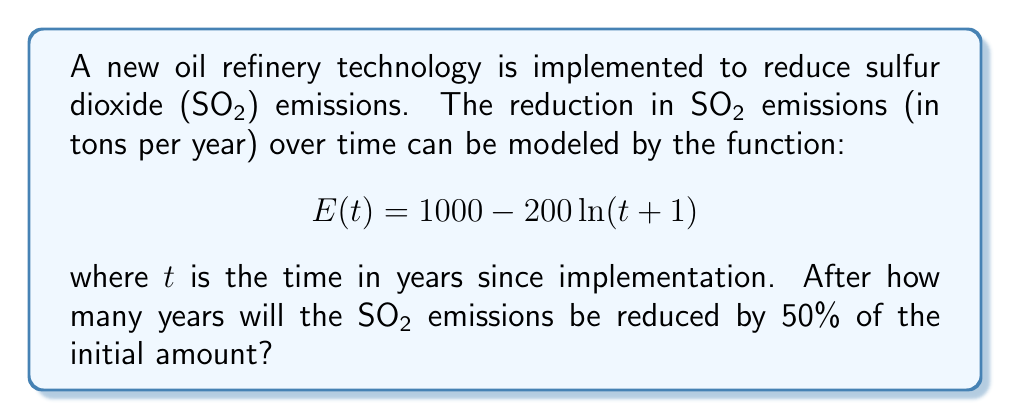Can you answer this question? Let's approach this step-by-step:

1) Initially, at $t=0$, the emissions are:
   $$E(0) = 1000 - 200 \ln(0+1) = 1000 - 200 \ln(1) = 1000$$

2) We want to find when emissions are reduced by 50%, so we're looking for:
   $$E(t) = 500$$

3) Let's set up the equation:
   $$500 = 1000 - 200 \ln(t+1)$$

4) Subtract 1000 from both sides:
   $$-500 = -200 \ln(t+1)$$

5) Divide both sides by -200:
   $$2.5 = \ln(t+1)$$

6) Apply $e^x$ to both sides:
   $$e^{2.5} = t+1$$

7) Subtract 1 from both sides:
   $$e^{2.5} - 1 = t$$

8) Calculate the value:
   $$t \approx 11.18$$

9) Since we can't have a fractional year in this context, we round up to the next whole year.
Answer: 12 years 